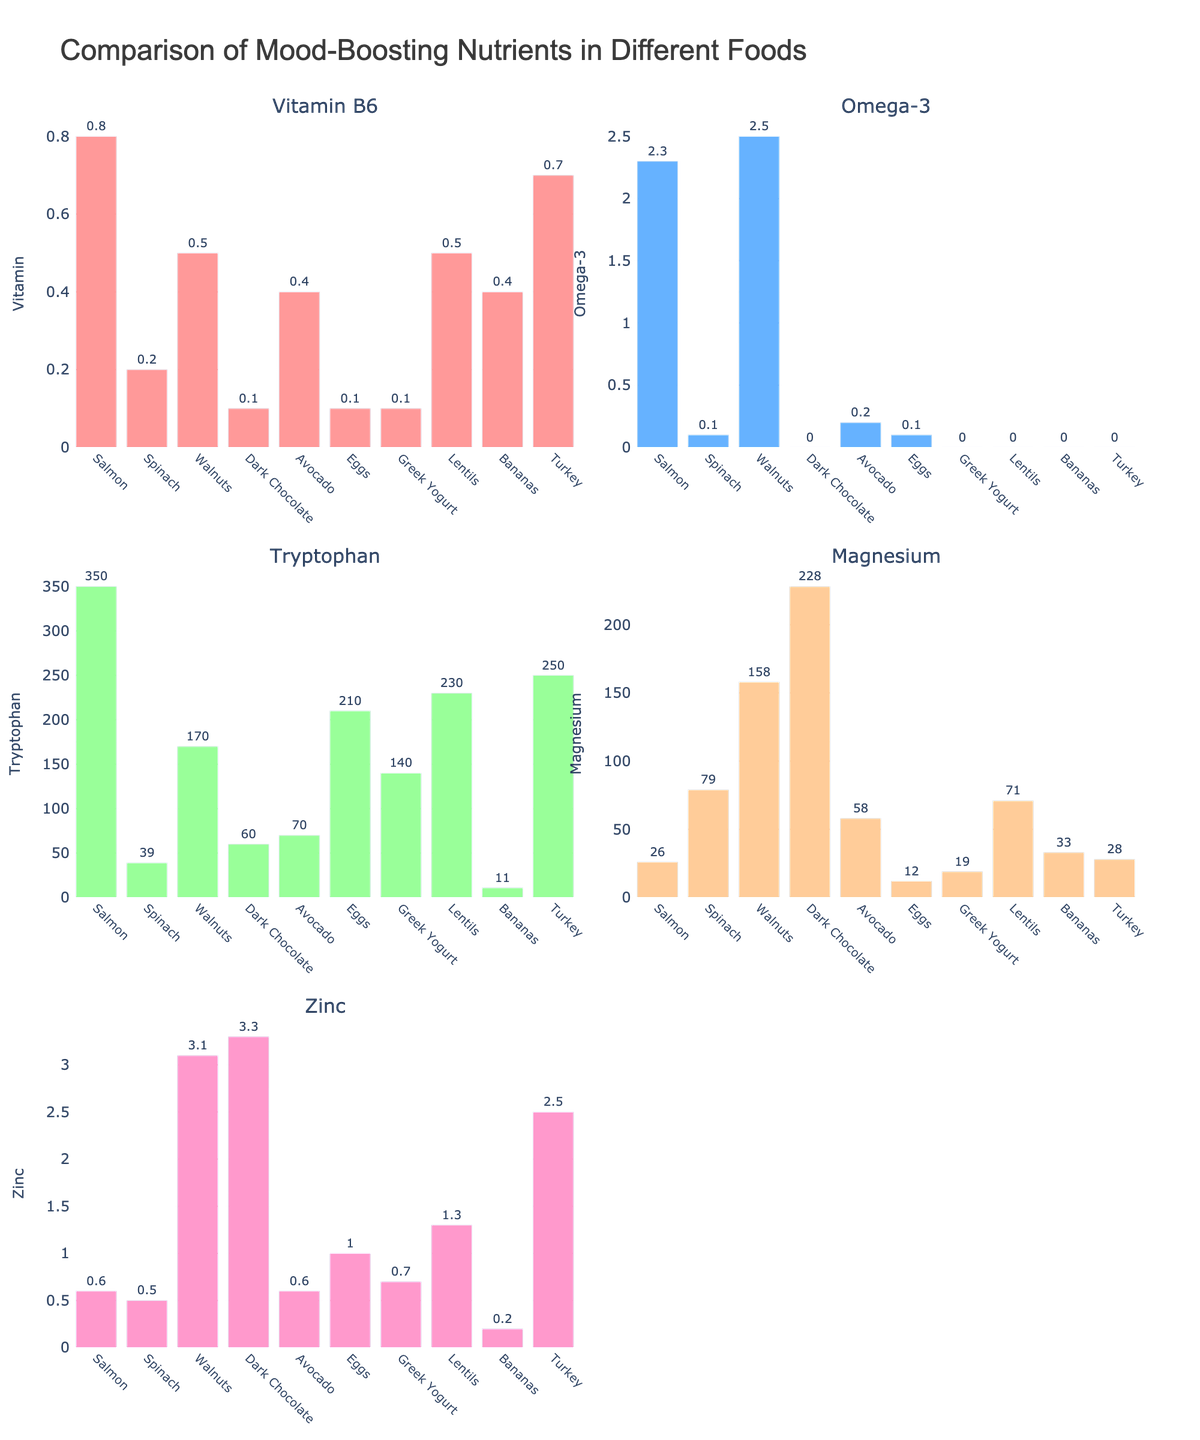What is the title of the figure? The title is located at the top center of the figure, and it provides a summary of what data the figure represents.
Answer: Environmental Impact of Outdoor Activities in Protected Areas Which activity generates the most waste per visitor? Check the heights of the bars in the "Waste Generation" subplot to see which is tallest.
Answer: Camping How many incidents of wildlife disturbance occur monthly due to rock climbing? Look at the bar labeled "Rock Climbing" in the "Wildlife Disturbance" subplot to find its height.
Answer: 18 Which activity causes less than 20 m²/year of vegetation damage? Check the bars in the "Vegetation Damage" subplot, focusing on those shorter than the 20 m² mark to identify the activity.
Answer: Hiking, Rock Climbing, Scenic Driving, Wildlife Watching Which two activities have the same amount of waste generation? Compare the bars in the "Waste Generation" subplot to find pairs that have the same height.
Answer: Mountain Biking and Wildlife Watching How is vegetation damage represented in the comparison scatter plot? Look at the color of the markers in the "Comparison of Impacts" subplot; the color gradient and scale should indicate vegetation damage.
Answer: Color intensity shows m²/year What is the total wildlife disturbance caused by mountain biking and fishing? Add the monthly incidents for both activities from the "Wildlife Disturbance" subplot.
Answer: 22 + 20 = 42 incidents/month Which activity shows the least impact in terms of waste generated, wildlife disturbance, and vegetation damage? Compare the positions of the activities in all three subplots together to find the minimum in each category.
Answer: Rock Climbing Is there a general correlation between waste generation and wildlife disturbance? Check the distribution of the scatter plot to see if the markers trend in a particular direction as one variable increases.
Answer: No strong correlation What activity has a similar environmental impact profile to hiking in terms of waste and wildlife disturbance? Compare waste and wildlife disturbance values of hiking with other activities in the corresponding subplots to find similar values.
Answer: Wildlife Watching 